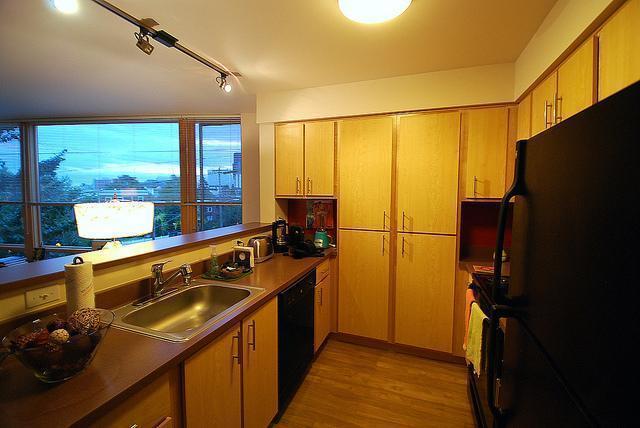What color is the light on top of the sink near the counter?
Make your selection from the four choices given to correctly answer the question.
Options: Orange, white, yellow, red. White. 